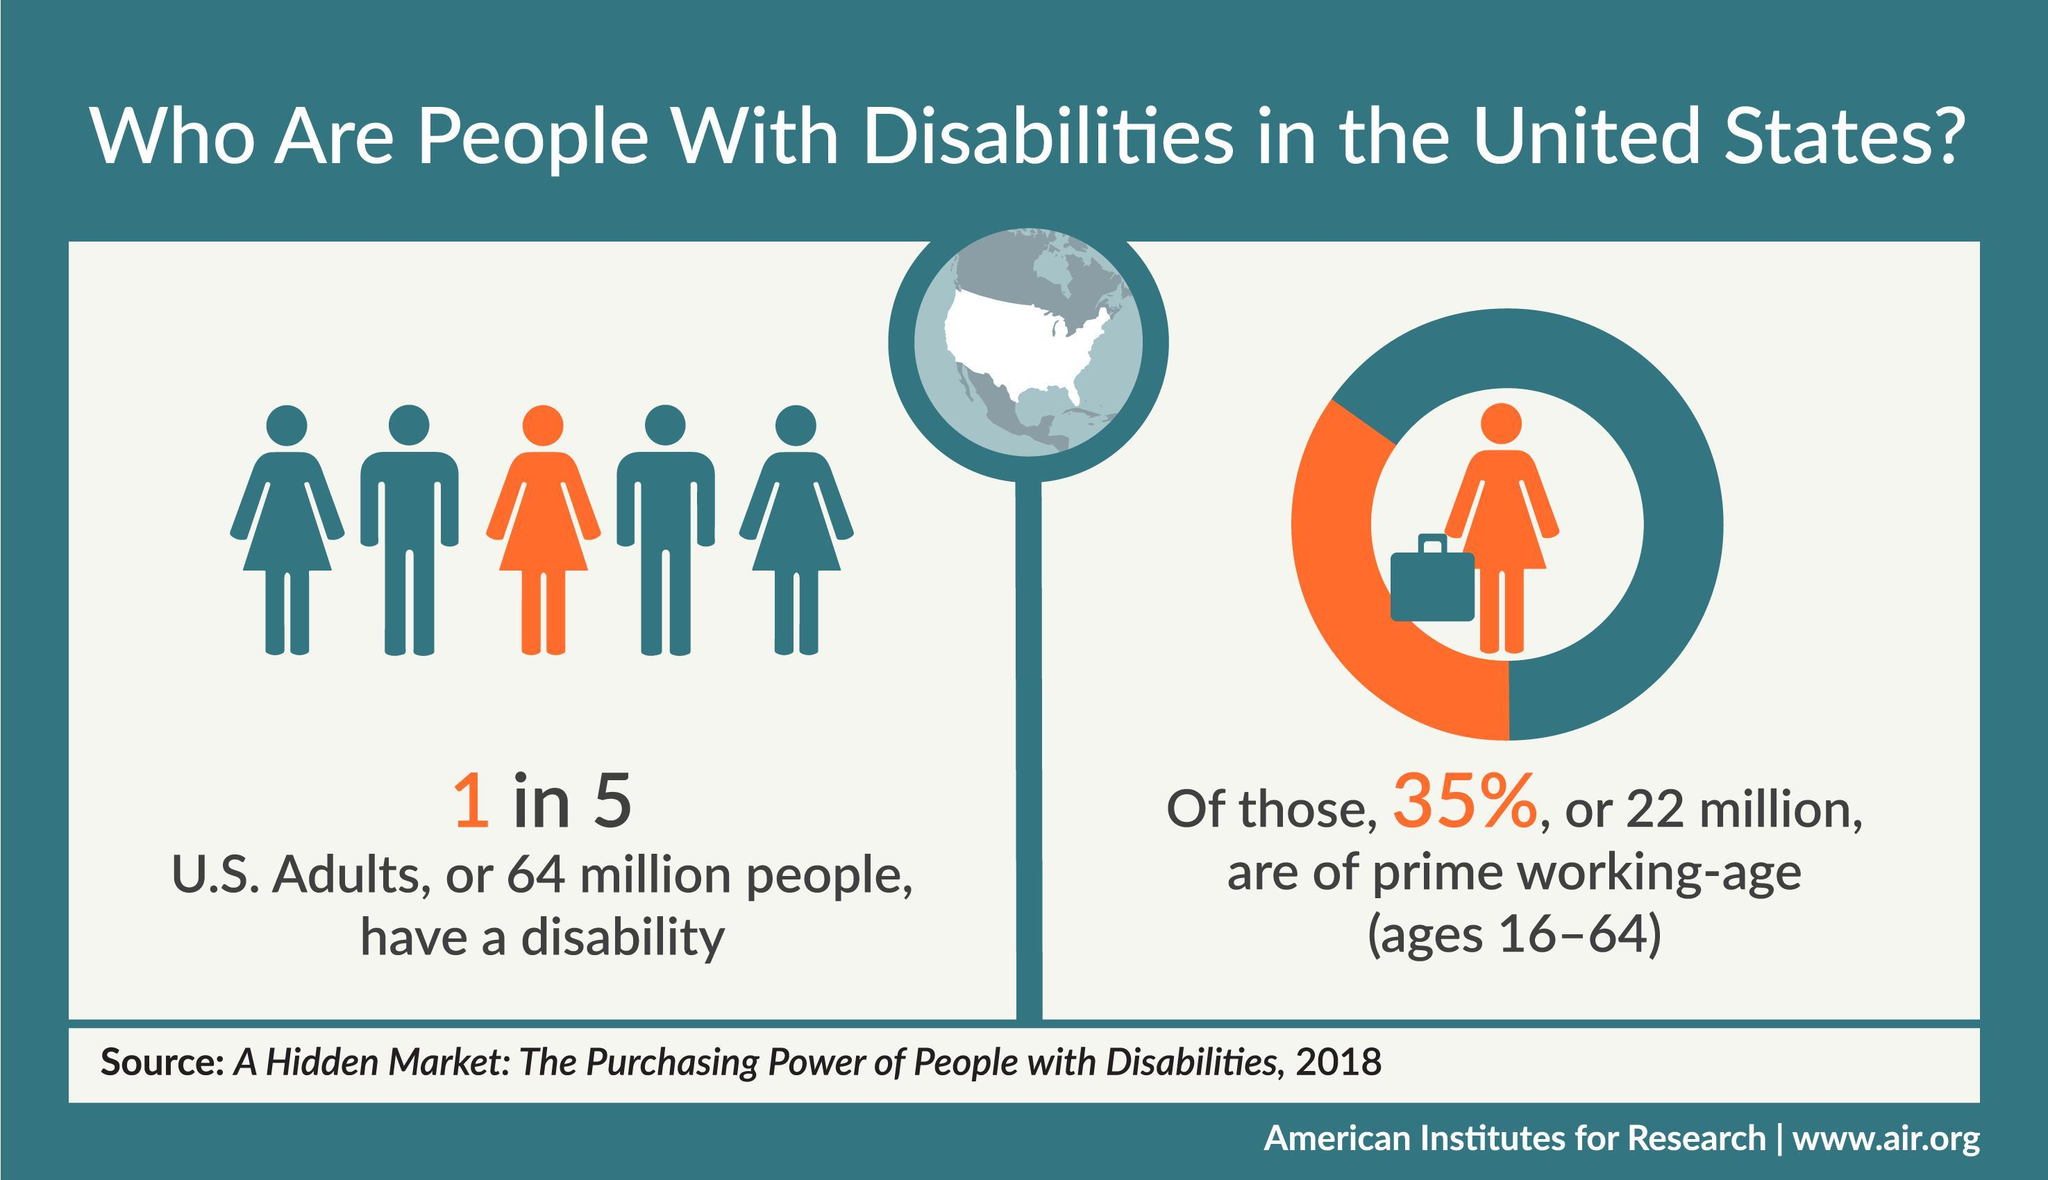What percentage of the disabled adults are not in the prime working age?
Answer the question with a short phrase. 65% Among the disabled adults, how many are not in the prime working age? 42 million 